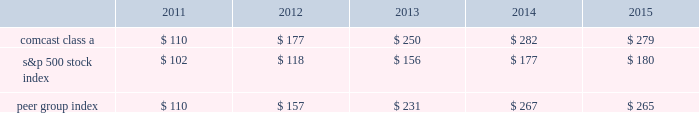Stock performance graph comcast the graph below compares the yearly percentage change in the cumulative total shareholder return on comcast 2019s class a common stock during the five years ended december 31 , 2015 with the cumulative total returns on the standard & poor 2019s 500 stock index and with a select peer group consisting of us and other companies engaged in the cable , communications and media industries .
This peer group consists of us , as well as cablevision systems corporation ( class a ) , dish network corporation ( class a ) , directv inc .
( included through july 24 , 2015 , the date of acquisition by at&t corp. ) and time warner cable inc .
( the 201ccable subgroup 201d ) , and time warner inc. , walt disney company , viacom inc .
( class b ) , twenty-first century fox , inc .
( class a ) , and cbs corporation ( class b ) ( the 201cmedia subgroup 201d ) .
The peer group was constructed as a composite peer group in which the cable subgroup is weighted 63% ( 63 % ) and the media subgroup is weighted 37% ( 37 % ) based on the respective revenue of our cable communications and nbcuniversal segments .
The graph assumes $ 100 was invested on december 31 , 2010 in our class a common stock and in each of the following indices and assumes the reinvestment of dividends .
Comparison of 5 year cumulative total return 12/1412/1312/1212/10 12/15 comcast class a s&p 500 peer group index .
Nbcuniversal nbcuniversal is a wholly owned subsidiary of nbcuniversal holdings and there is no market for its equity securities .
39 comcast 2015 annual report on form 10-k .
What was the percentage 5 year cumulative total return for comcast class a stock for the year ended 2015? 
Computations: ((279 - 100) / 100)
Answer: 1.79. 